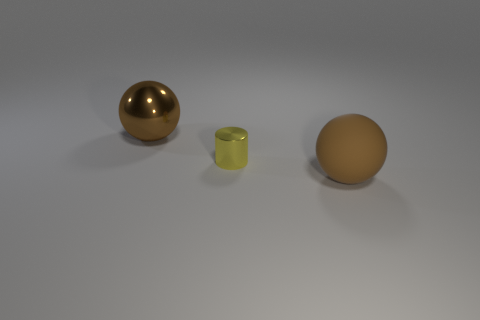Add 2 big brown spheres. How many objects exist? 5 Add 1 brown shiny things. How many brown shiny things exist? 2 Subtract 0 blue cylinders. How many objects are left? 3 Subtract all balls. How many objects are left? 1 Subtract all purple spheres. Subtract all gray cubes. How many spheres are left? 2 Subtract all brown matte spheres. Subtract all metallic things. How many objects are left? 0 Add 2 brown shiny balls. How many brown shiny balls are left? 3 